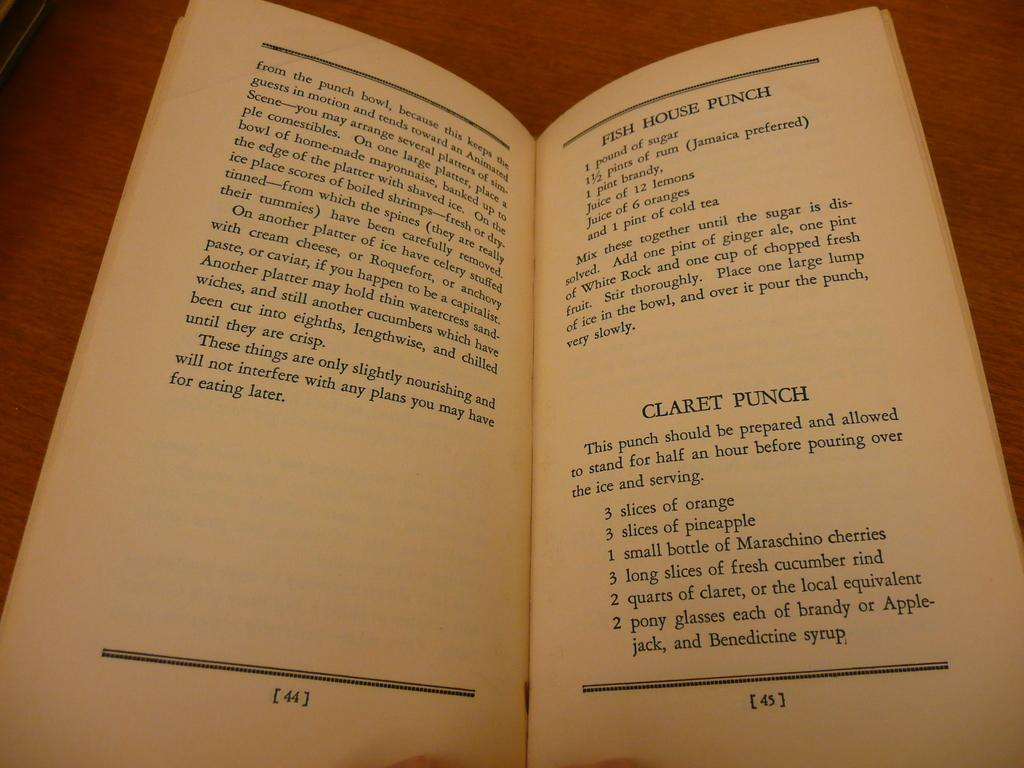<image>
Offer a succinct explanation of the picture presented. Recipe book set on page 45 that is named "Fish House Punch". 